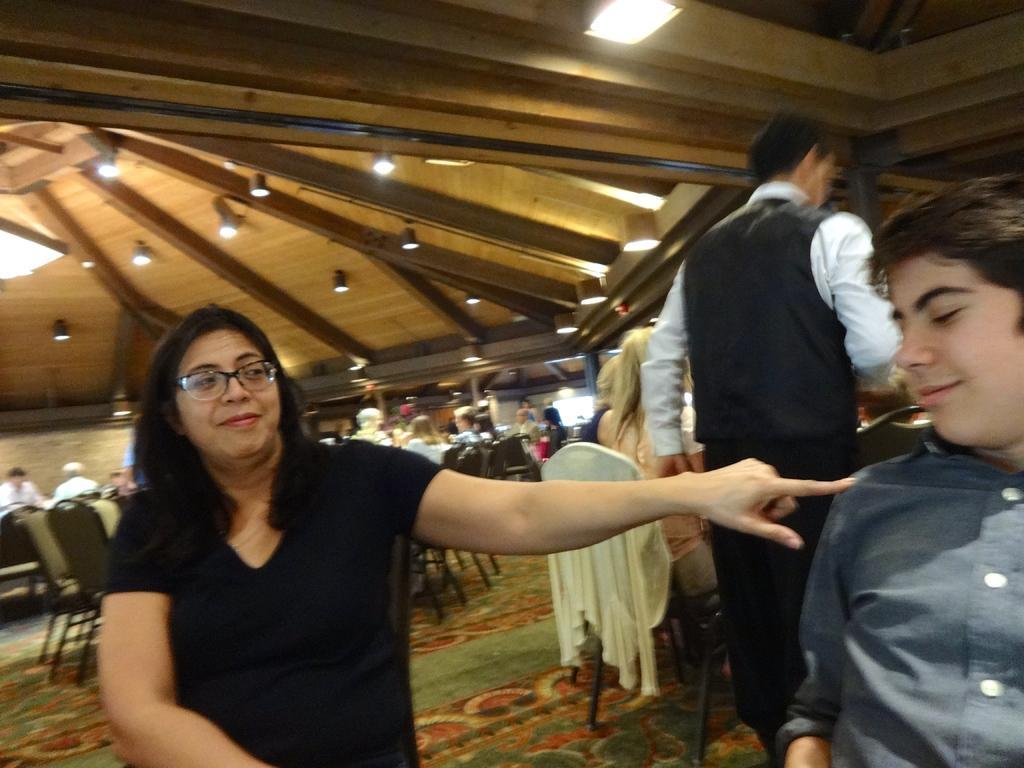In one or two sentences, can you explain what this image depicts? In this image a woman wearing a black shirt is wearing spectacles. Right side there is a person wearing a shirt. Behind there is a person standing on the floor. There is a chair having cloth on it. A woman is sitting on the chair. Background few persons are sitting on the chairs. Top of image there are few lights attached to the roof. 